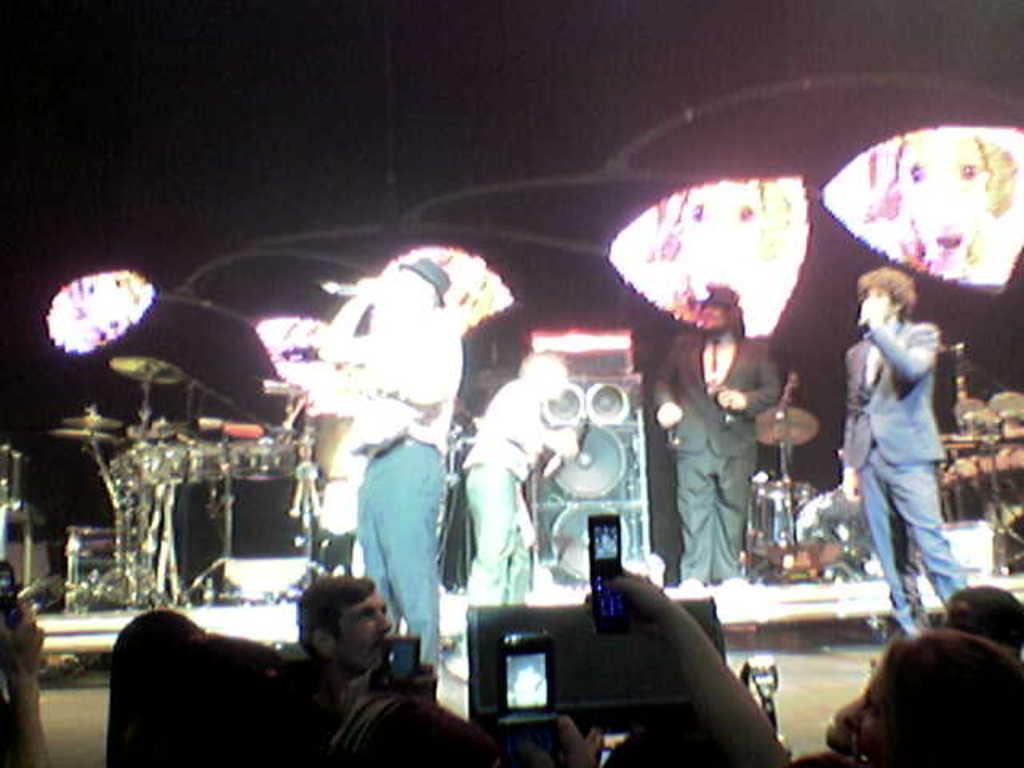Please provide a concise description of this image. In the image it looks like a concert there are a group of people performing on the stage, some of them are singing and behind them there are speakers and many musical instruments. The crowd standing in front of them are taking photographs and in the background there are different color lights. 